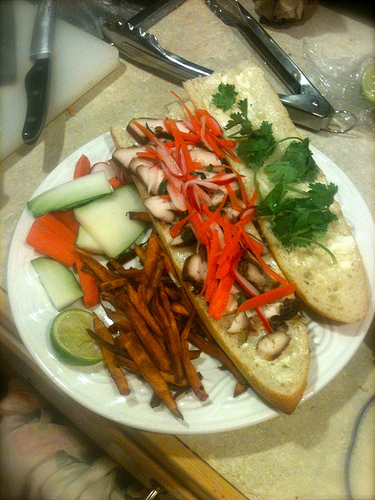<image>
Is the bun under the tongs? No. The bun is not positioned under the tongs. The vertical relationship between these objects is different. 